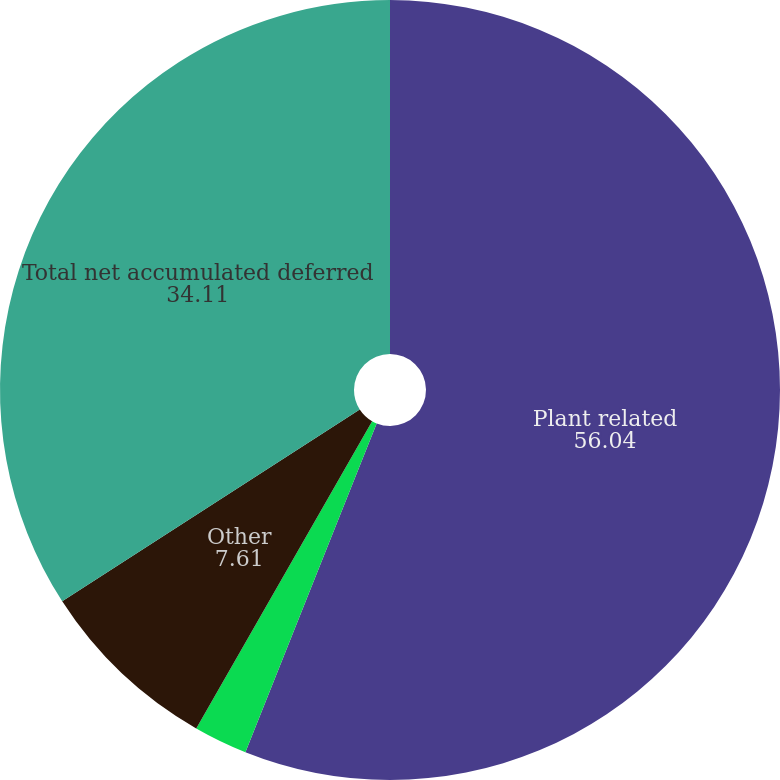<chart> <loc_0><loc_0><loc_500><loc_500><pie_chart><fcel>Plant related<fcel>Deferred benefit costs<fcel>Other<fcel>Total net accumulated deferred<nl><fcel>56.04%<fcel>2.23%<fcel>7.61%<fcel>34.11%<nl></chart> 